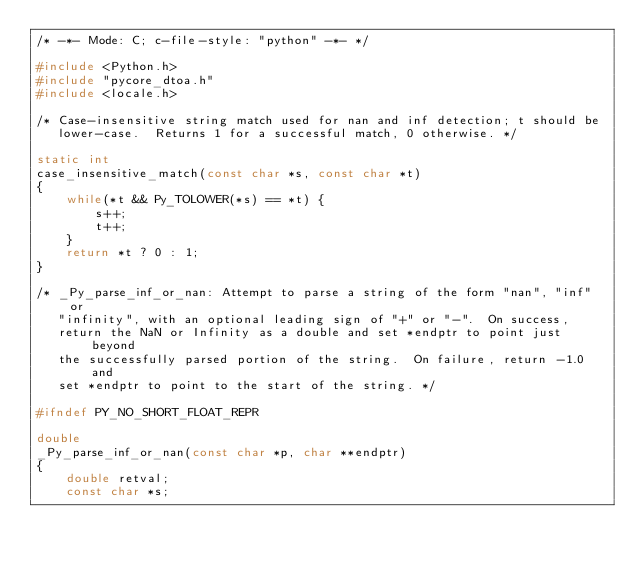Convert code to text. <code><loc_0><loc_0><loc_500><loc_500><_C_>/* -*- Mode: C; c-file-style: "python" -*- */

#include <Python.h>
#include "pycore_dtoa.h"
#include <locale.h>

/* Case-insensitive string match used for nan and inf detection; t should be
   lower-case.  Returns 1 for a successful match, 0 otherwise. */

static int
case_insensitive_match(const char *s, const char *t)
{
    while(*t && Py_TOLOWER(*s) == *t) {
        s++;
        t++;
    }
    return *t ? 0 : 1;
}

/* _Py_parse_inf_or_nan: Attempt to parse a string of the form "nan", "inf" or
   "infinity", with an optional leading sign of "+" or "-".  On success,
   return the NaN or Infinity as a double and set *endptr to point just beyond
   the successfully parsed portion of the string.  On failure, return -1.0 and
   set *endptr to point to the start of the string. */

#ifndef PY_NO_SHORT_FLOAT_REPR

double
_Py_parse_inf_or_nan(const char *p, char **endptr)
{
    double retval;
    const char *s;</code> 